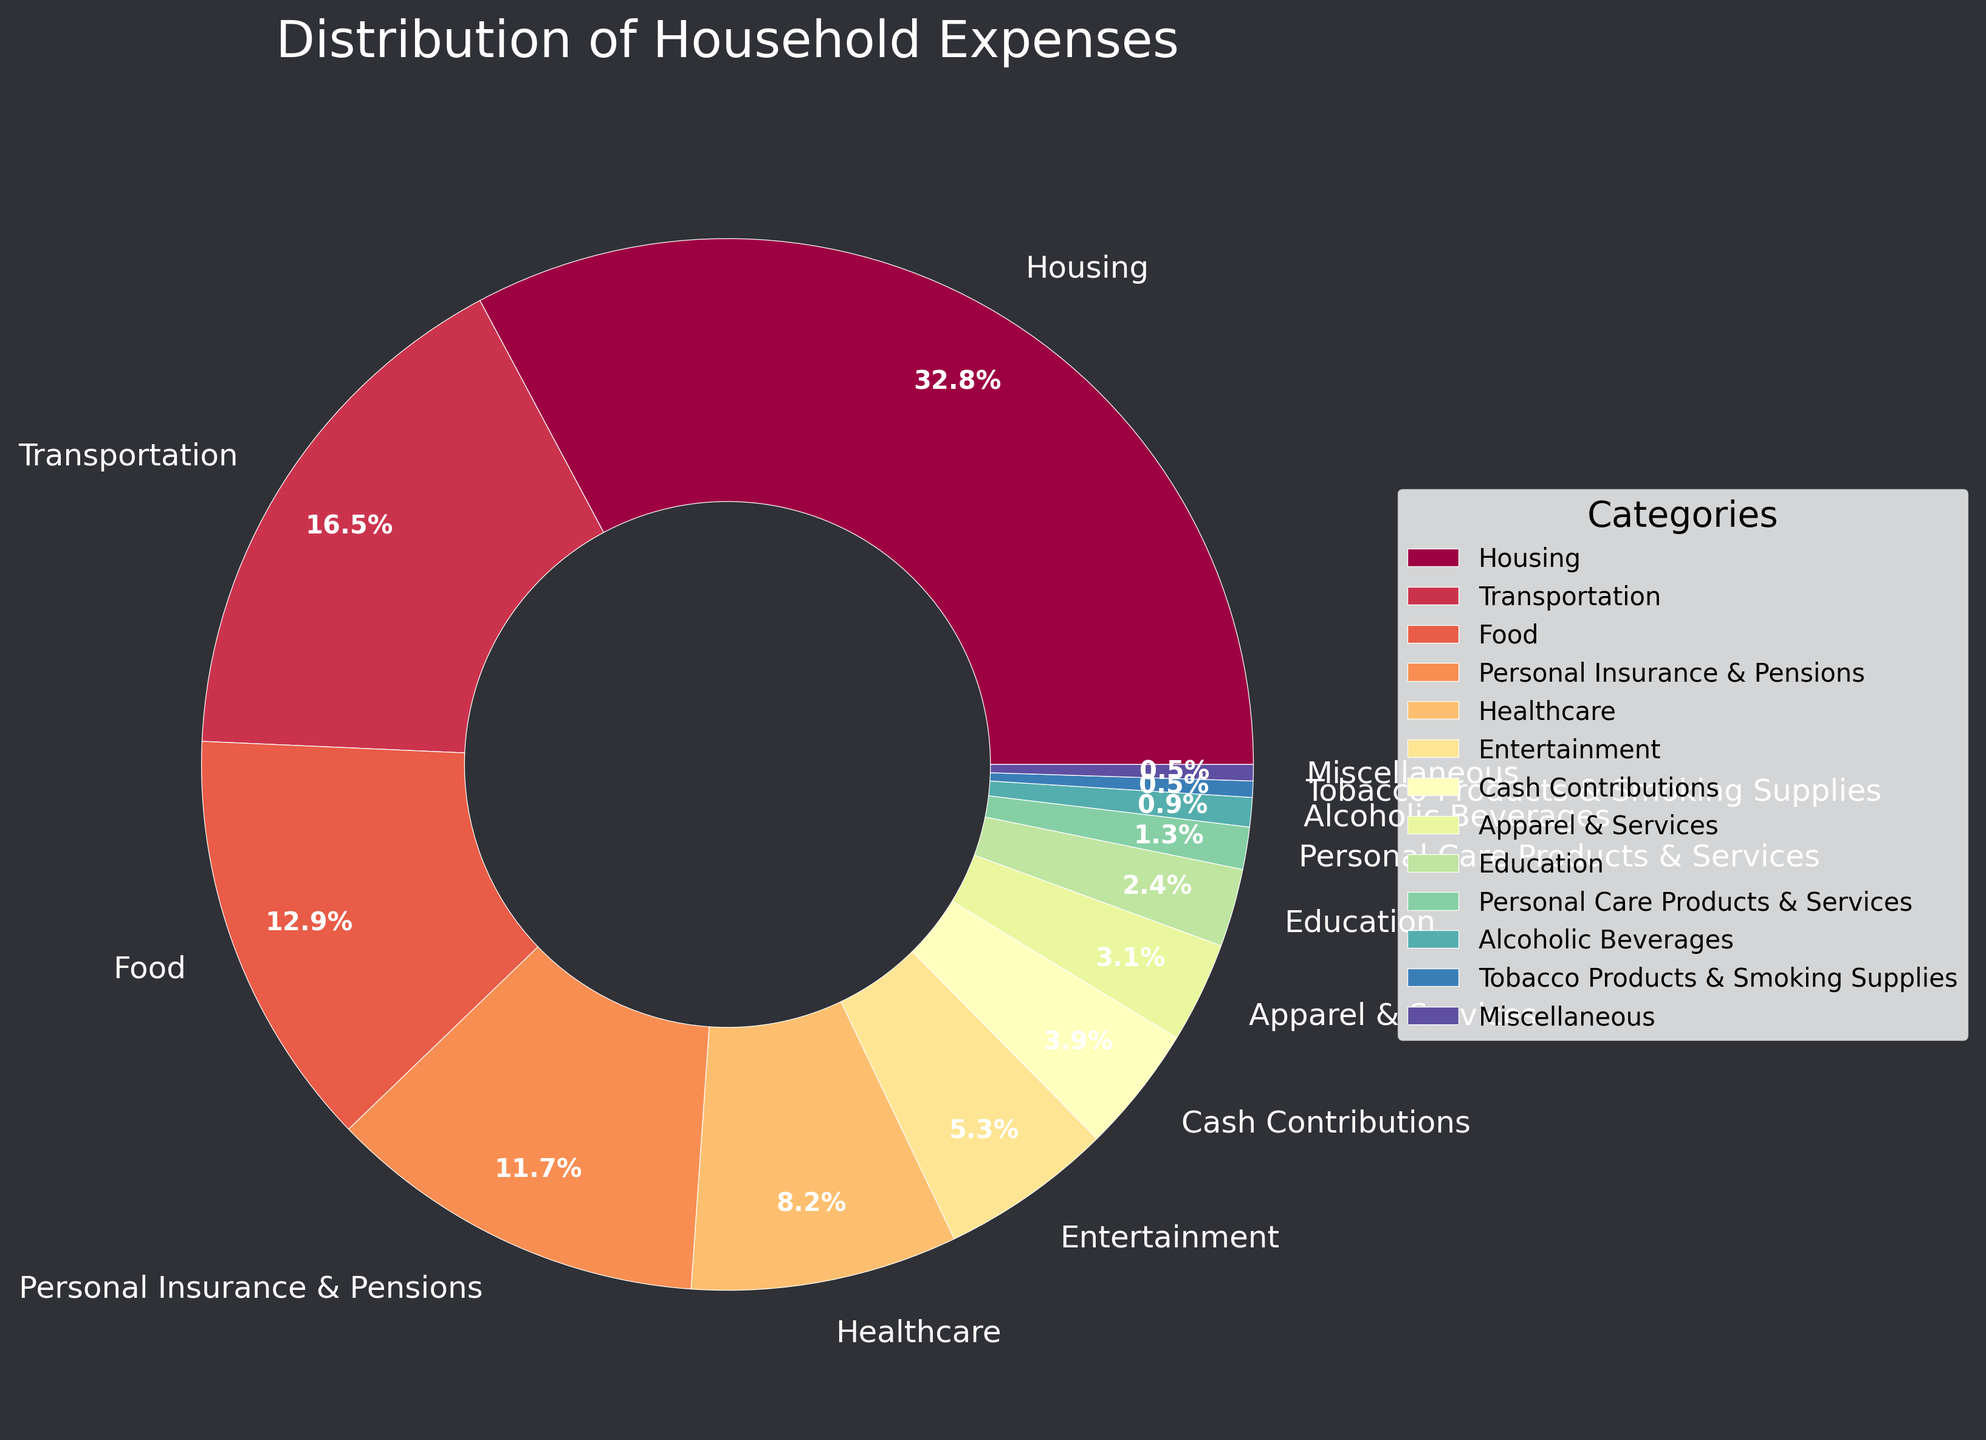Which category has the highest percentage of household expenses? Look at the pie chart and identify which category has the largest slice. The Housing category occupies the most space.
Answer: Housing Which category has the smallest percentage of household expenses? Locate the smallest slice in the pie chart. The Tobacco Products & Smoking Supplies and Miscellaneous categories have the smallest slices.
Answer: Tobacco Products & Smoking Supplies, Miscellaneous What is the combined percentage of expenses for Food and Healthcare? Find the percentages for Food (12.9%) and Healthcare (8.2%). Add them together: 12.9% + 8.2% = 21.1%.
Answer: 21.1% How much more is spent on Housing compared to Education? Check the percentages for Housing (32.8%) and Education (2.4%). Subtract Education from Housing: 32.8% - 2.4% = 30.4%.
Answer: 30.4% Is the percentage spent on Transportation greater than Personal Insurance & Pensions? Compare the percentages for Transportation (16.5%) and Personal Insurance & Pensions (11.7%). Transportation is greater.
Answer: Yes What is the combined percentage of the three smallest categories? Identify the percentages for the three smallest categories: Tobacco Products & Smoking Supplies (0.5%), Miscellaneous (0.5%), Alcoholic Beverages (0.9%). Add them together: 0.5% + 0.5% + 0.9% = 1.9%.
Answer: 1.9% Which two categories combined have a higher percentage: Entertainment and Cash Contributions or Healthcare and Apparel & Services? Entertainment (5.3%) + Cash Contributions (3.9%) = 9.2%. Healthcare (8.2%) + Apparel & Services (3.1%) = 11.3%. Healthcare and Apparel & Services combined are higher.
Answer: Healthcare and Apparel & Services What is the difference in percentage between Personal Care Products & Services and Entertainment? Locate the percentages for Personal Care Products & Services (1.3%) and Entertainment (5.3%). Subtract Personal Care Products & Services from Entertainment: 5.3% - 1.3% = 4.0%.
Answer: 4.0% Which categories have more than 10% of household expenses? Identify all categories with percentages greater than 10%. Housing (32.8%), Transportation (16.5%), Food (12.9%), and Personal Insurance & Pensions (11.7%) all meet this criterion.
Answer: Housing, Transportation, Food, Personal Insurance & Pensions 